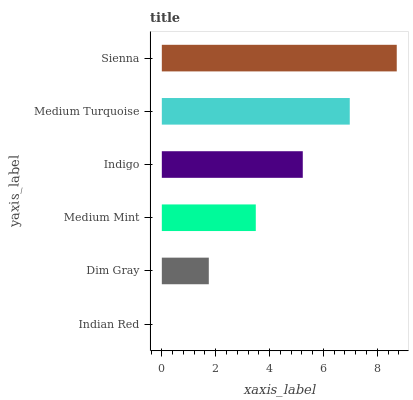Is Indian Red the minimum?
Answer yes or no. Yes. Is Sienna the maximum?
Answer yes or no. Yes. Is Dim Gray the minimum?
Answer yes or no. No. Is Dim Gray the maximum?
Answer yes or no. No. Is Dim Gray greater than Indian Red?
Answer yes or no. Yes. Is Indian Red less than Dim Gray?
Answer yes or no. Yes. Is Indian Red greater than Dim Gray?
Answer yes or no. No. Is Dim Gray less than Indian Red?
Answer yes or no. No. Is Indigo the high median?
Answer yes or no. Yes. Is Medium Mint the low median?
Answer yes or no. Yes. Is Medium Mint the high median?
Answer yes or no. No. Is Sienna the low median?
Answer yes or no. No. 